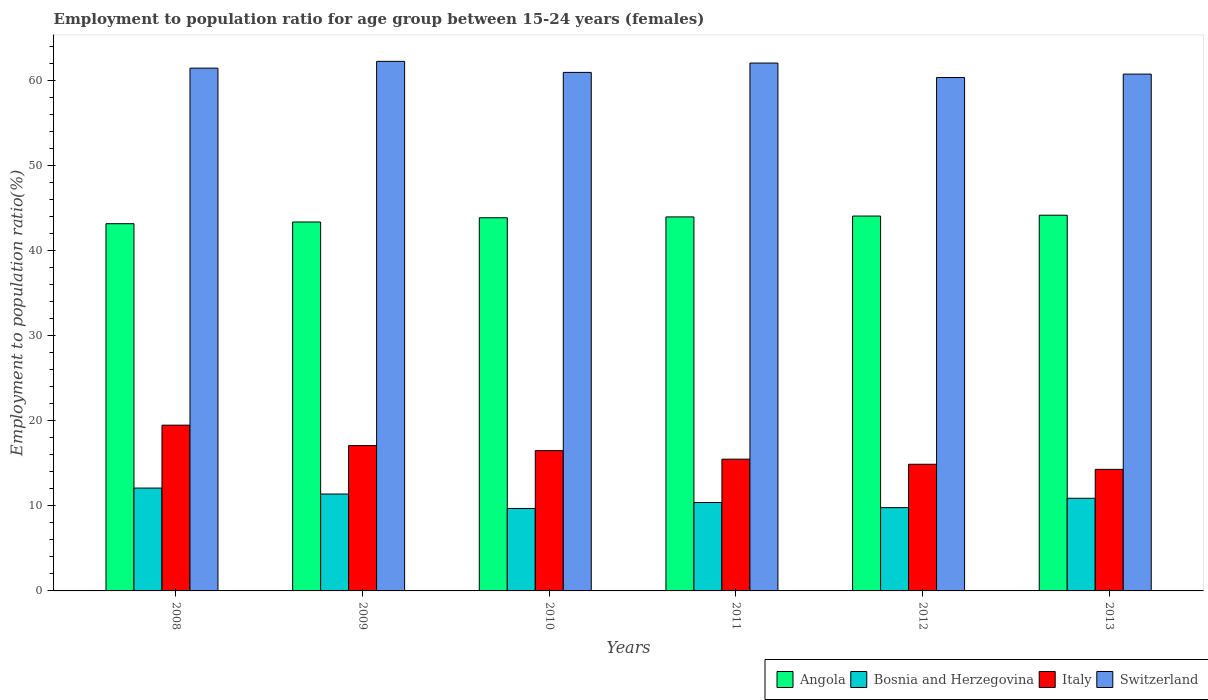How many different coloured bars are there?
Offer a very short reply. 4. How many bars are there on the 2nd tick from the left?
Provide a succinct answer. 4. How many bars are there on the 2nd tick from the right?
Your answer should be compact. 4. What is the employment to population ratio in Switzerland in 2010?
Provide a short and direct response. 61. Across all years, what is the minimum employment to population ratio in Bosnia and Herzegovina?
Your answer should be very brief. 9.7. What is the total employment to population ratio in Angola in the graph?
Keep it short and to the point. 262.8. What is the difference between the employment to population ratio in Bosnia and Herzegovina in 2011 and that in 2012?
Keep it short and to the point. 0.6. What is the difference between the employment to population ratio in Switzerland in 2010 and the employment to population ratio in Italy in 2009?
Your answer should be very brief. 43.9. What is the average employment to population ratio in Switzerland per year?
Your response must be concise. 61.35. In the year 2012, what is the difference between the employment to population ratio in Italy and employment to population ratio in Angola?
Make the answer very short. -29.2. What is the ratio of the employment to population ratio in Italy in 2009 to that in 2013?
Keep it short and to the point. 1.2. What is the difference between the highest and the second highest employment to population ratio in Angola?
Ensure brevity in your answer.  0.1. What is the difference between the highest and the lowest employment to population ratio in Italy?
Offer a terse response. 5.2. Is the sum of the employment to population ratio in Bosnia and Herzegovina in 2008 and 2012 greater than the maximum employment to population ratio in Switzerland across all years?
Your answer should be compact. No. What does the 1st bar from the left in 2012 represents?
Ensure brevity in your answer.  Angola. Does the graph contain grids?
Keep it short and to the point. No. Where does the legend appear in the graph?
Provide a short and direct response. Bottom right. How are the legend labels stacked?
Offer a very short reply. Horizontal. What is the title of the graph?
Make the answer very short. Employment to population ratio for age group between 15-24 years (females). What is the label or title of the Y-axis?
Ensure brevity in your answer.  Employment to population ratio(%). What is the Employment to population ratio(%) of Angola in 2008?
Your response must be concise. 43.2. What is the Employment to population ratio(%) in Bosnia and Herzegovina in 2008?
Give a very brief answer. 12.1. What is the Employment to population ratio(%) of Switzerland in 2008?
Keep it short and to the point. 61.5. What is the Employment to population ratio(%) of Angola in 2009?
Offer a terse response. 43.4. What is the Employment to population ratio(%) in Bosnia and Herzegovina in 2009?
Your answer should be compact. 11.4. What is the Employment to population ratio(%) of Italy in 2009?
Offer a terse response. 17.1. What is the Employment to population ratio(%) in Switzerland in 2009?
Offer a terse response. 62.3. What is the Employment to population ratio(%) of Angola in 2010?
Give a very brief answer. 43.9. What is the Employment to population ratio(%) of Bosnia and Herzegovina in 2010?
Make the answer very short. 9.7. What is the Employment to population ratio(%) in Italy in 2010?
Offer a very short reply. 16.5. What is the Employment to population ratio(%) of Switzerland in 2010?
Give a very brief answer. 61. What is the Employment to population ratio(%) in Bosnia and Herzegovina in 2011?
Provide a succinct answer. 10.4. What is the Employment to population ratio(%) in Italy in 2011?
Your response must be concise. 15.5. What is the Employment to population ratio(%) of Switzerland in 2011?
Offer a terse response. 62.1. What is the Employment to population ratio(%) in Angola in 2012?
Your answer should be very brief. 44.1. What is the Employment to population ratio(%) in Bosnia and Herzegovina in 2012?
Make the answer very short. 9.8. What is the Employment to population ratio(%) of Italy in 2012?
Offer a terse response. 14.9. What is the Employment to population ratio(%) of Switzerland in 2012?
Your answer should be compact. 60.4. What is the Employment to population ratio(%) in Angola in 2013?
Offer a very short reply. 44.2. What is the Employment to population ratio(%) of Bosnia and Herzegovina in 2013?
Provide a short and direct response. 10.9. What is the Employment to population ratio(%) of Italy in 2013?
Make the answer very short. 14.3. What is the Employment to population ratio(%) in Switzerland in 2013?
Provide a short and direct response. 60.8. Across all years, what is the maximum Employment to population ratio(%) of Angola?
Provide a succinct answer. 44.2. Across all years, what is the maximum Employment to population ratio(%) in Bosnia and Herzegovina?
Your answer should be very brief. 12.1. Across all years, what is the maximum Employment to population ratio(%) in Switzerland?
Keep it short and to the point. 62.3. Across all years, what is the minimum Employment to population ratio(%) of Angola?
Ensure brevity in your answer.  43.2. Across all years, what is the minimum Employment to population ratio(%) in Bosnia and Herzegovina?
Provide a succinct answer. 9.7. Across all years, what is the minimum Employment to population ratio(%) in Italy?
Your answer should be compact. 14.3. Across all years, what is the minimum Employment to population ratio(%) in Switzerland?
Give a very brief answer. 60.4. What is the total Employment to population ratio(%) of Angola in the graph?
Give a very brief answer. 262.8. What is the total Employment to population ratio(%) of Bosnia and Herzegovina in the graph?
Give a very brief answer. 64.3. What is the total Employment to population ratio(%) in Italy in the graph?
Give a very brief answer. 97.8. What is the total Employment to population ratio(%) of Switzerland in the graph?
Provide a short and direct response. 368.1. What is the difference between the Employment to population ratio(%) of Angola in 2008 and that in 2009?
Ensure brevity in your answer.  -0.2. What is the difference between the Employment to population ratio(%) of Bosnia and Herzegovina in 2008 and that in 2009?
Your answer should be very brief. 0.7. What is the difference between the Employment to population ratio(%) of Italy in 2008 and that in 2009?
Give a very brief answer. 2.4. What is the difference between the Employment to population ratio(%) in Switzerland in 2008 and that in 2009?
Your response must be concise. -0.8. What is the difference between the Employment to population ratio(%) of Bosnia and Herzegovina in 2008 and that in 2010?
Your response must be concise. 2.4. What is the difference between the Employment to population ratio(%) of Switzerland in 2008 and that in 2010?
Offer a very short reply. 0.5. What is the difference between the Employment to population ratio(%) of Italy in 2008 and that in 2011?
Provide a short and direct response. 4. What is the difference between the Employment to population ratio(%) of Switzerland in 2008 and that in 2012?
Your response must be concise. 1.1. What is the difference between the Employment to population ratio(%) in Angola in 2008 and that in 2013?
Keep it short and to the point. -1. What is the difference between the Employment to population ratio(%) in Bosnia and Herzegovina in 2008 and that in 2013?
Your answer should be very brief. 1.2. What is the difference between the Employment to population ratio(%) of Italy in 2008 and that in 2013?
Your answer should be very brief. 5.2. What is the difference between the Employment to population ratio(%) in Switzerland in 2008 and that in 2013?
Provide a succinct answer. 0.7. What is the difference between the Employment to population ratio(%) of Angola in 2009 and that in 2010?
Provide a succinct answer. -0.5. What is the difference between the Employment to population ratio(%) of Italy in 2009 and that in 2010?
Provide a short and direct response. 0.6. What is the difference between the Employment to population ratio(%) in Angola in 2009 and that in 2011?
Your response must be concise. -0.6. What is the difference between the Employment to population ratio(%) of Bosnia and Herzegovina in 2009 and that in 2011?
Make the answer very short. 1. What is the difference between the Employment to population ratio(%) in Italy in 2009 and that in 2011?
Your answer should be compact. 1.6. What is the difference between the Employment to population ratio(%) of Switzerland in 2009 and that in 2011?
Give a very brief answer. 0.2. What is the difference between the Employment to population ratio(%) in Switzerland in 2009 and that in 2012?
Make the answer very short. 1.9. What is the difference between the Employment to population ratio(%) of Bosnia and Herzegovina in 2009 and that in 2013?
Make the answer very short. 0.5. What is the difference between the Employment to population ratio(%) in Switzerland in 2010 and that in 2011?
Make the answer very short. -1.1. What is the difference between the Employment to population ratio(%) of Bosnia and Herzegovina in 2010 and that in 2012?
Provide a succinct answer. -0.1. What is the difference between the Employment to population ratio(%) of Angola in 2010 and that in 2013?
Your answer should be very brief. -0.3. What is the difference between the Employment to population ratio(%) in Bosnia and Herzegovina in 2010 and that in 2013?
Give a very brief answer. -1.2. What is the difference between the Employment to population ratio(%) of Angola in 2011 and that in 2012?
Keep it short and to the point. -0.1. What is the difference between the Employment to population ratio(%) of Italy in 2011 and that in 2012?
Your response must be concise. 0.6. What is the difference between the Employment to population ratio(%) of Angola in 2011 and that in 2013?
Your response must be concise. -0.2. What is the difference between the Employment to population ratio(%) of Italy in 2011 and that in 2013?
Give a very brief answer. 1.2. What is the difference between the Employment to population ratio(%) of Switzerland in 2011 and that in 2013?
Make the answer very short. 1.3. What is the difference between the Employment to population ratio(%) in Italy in 2012 and that in 2013?
Offer a very short reply. 0.6. What is the difference between the Employment to population ratio(%) of Switzerland in 2012 and that in 2013?
Keep it short and to the point. -0.4. What is the difference between the Employment to population ratio(%) of Angola in 2008 and the Employment to population ratio(%) of Bosnia and Herzegovina in 2009?
Give a very brief answer. 31.8. What is the difference between the Employment to population ratio(%) in Angola in 2008 and the Employment to population ratio(%) in Italy in 2009?
Make the answer very short. 26.1. What is the difference between the Employment to population ratio(%) of Angola in 2008 and the Employment to population ratio(%) of Switzerland in 2009?
Offer a terse response. -19.1. What is the difference between the Employment to population ratio(%) of Bosnia and Herzegovina in 2008 and the Employment to population ratio(%) of Switzerland in 2009?
Keep it short and to the point. -50.2. What is the difference between the Employment to population ratio(%) of Italy in 2008 and the Employment to population ratio(%) of Switzerland in 2009?
Provide a succinct answer. -42.8. What is the difference between the Employment to population ratio(%) in Angola in 2008 and the Employment to population ratio(%) in Bosnia and Herzegovina in 2010?
Your answer should be compact. 33.5. What is the difference between the Employment to population ratio(%) in Angola in 2008 and the Employment to population ratio(%) in Italy in 2010?
Give a very brief answer. 26.7. What is the difference between the Employment to population ratio(%) in Angola in 2008 and the Employment to population ratio(%) in Switzerland in 2010?
Ensure brevity in your answer.  -17.8. What is the difference between the Employment to population ratio(%) in Bosnia and Herzegovina in 2008 and the Employment to population ratio(%) in Italy in 2010?
Offer a very short reply. -4.4. What is the difference between the Employment to population ratio(%) of Bosnia and Herzegovina in 2008 and the Employment to population ratio(%) of Switzerland in 2010?
Offer a terse response. -48.9. What is the difference between the Employment to population ratio(%) in Italy in 2008 and the Employment to population ratio(%) in Switzerland in 2010?
Your answer should be compact. -41.5. What is the difference between the Employment to population ratio(%) of Angola in 2008 and the Employment to population ratio(%) of Bosnia and Herzegovina in 2011?
Your answer should be compact. 32.8. What is the difference between the Employment to population ratio(%) of Angola in 2008 and the Employment to population ratio(%) of Italy in 2011?
Ensure brevity in your answer.  27.7. What is the difference between the Employment to population ratio(%) in Angola in 2008 and the Employment to population ratio(%) in Switzerland in 2011?
Your answer should be compact. -18.9. What is the difference between the Employment to population ratio(%) in Italy in 2008 and the Employment to population ratio(%) in Switzerland in 2011?
Keep it short and to the point. -42.6. What is the difference between the Employment to population ratio(%) of Angola in 2008 and the Employment to population ratio(%) of Bosnia and Herzegovina in 2012?
Provide a short and direct response. 33.4. What is the difference between the Employment to population ratio(%) in Angola in 2008 and the Employment to population ratio(%) in Italy in 2012?
Give a very brief answer. 28.3. What is the difference between the Employment to population ratio(%) of Angola in 2008 and the Employment to population ratio(%) of Switzerland in 2012?
Your response must be concise. -17.2. What is the difference between the Employment to population ratio(%) in Bosnia and Herzegovina in 2008 and the Employment to population ratio(%) in Switzerland in 2012?
Provide a succinct answer. -48.3. What is the difference between the Employment to population ratio(%) in Italy in 2008 and the Employment to population ratio(%) in Switzerland in 2012?
Keep it short and to the point. -40.9. What is the difference between the Employment to population ratio(%) of Angola in 2008 and the Employment to population ratio(%) of Bosnia and Herzegovina in 2013?
Provide a succinct answer. 32.3. What is the difference between the Employment to population ratio(%) of Angola in 2008 and the Employment to population ratio(%) of Italy in 2013?
Give a very brief answer. 28.9. What is the difference between the Employment to population ratio(%) of Angola in 2008 and the Employment to population ratio(%) of Switzerland in 2013?
Offer a terse response. -17.6. What is the difference between the Employment to population ratio(%) in Bosnia and Herzegovina in 2008 and the Employment to population ratio(%) in Switzerland in 2013?
Ensure brevity in your answer.  -48.7. What is the difference between the Employment to population ratio(%) in Italy in 2008 and the Employment to population ratio(%) in Switzerland in 2013?
Your response must be concise. -41.3. What is the difference between the Employment to population ratio(%) of Angola in 2009 and the Employment to population ratio(%) of Bosnia and Herzegovina in 2010?
Provide a short and direct response. 33.7. What is the difference between the Employment to population ratio(%) of Angola in 2009 and the Employment to population ratio(%) of Italy in 2010?
Provide a short and direct response. 26.9. What is the difference between the Employment to population ratio(%) of Angola in 2009 and the Employment to population ratio(%) of Switzerland in 2010?
Your response must be concise. -17.6. What is the difference between the Employment to population ratio(%) in Bosnia and Herzegovina in 2009 and the Employment to population ratio(%) in Switzerland in 2010?
Keep it short and to the point. -49.6. What is the difference between the Employment to population ratio(%) in Italy in 2009 and the Employment to population ratio(%) in Switzerland in 2010?
Offer a very short reply. -43.9. What is the difference between the Employment to population ratio(%) in Angola in 2009 and the Employment to population ratio(%) in Bosnia and Herzegovina in 2011?
Your response must be concise. 33. What is the difference between the Employment to population ratio(%) in Angola in 2009 and the Employment to population ratio(%) in Italy in 2011?
Your response must be concise. 27.9. What is the difference between the Employment to population ratio(%) in Angola in 2009 and the Employment to population ratio(%) in Switzerland in 2011?
Offer a terse response. -18.7. What is the difference between the Employment to population ratio(%) in Bosnia and Herzegovina in 2009 and the Employment to population ratio(%) in Switzerland in 2011?
Ensure brevity in your answer.  -50.7. What is the difference between the Employment to population ratio(%) in Italy in 2009 and the Employment to population ratio(%) in Switzerland in 2011?
Provide a short and direct response. -45. What is the difference between the Employment to population ratio(%) in Angola in 2009 and the Employment to population ratio(%) in Bosnia and Herzegovina in 2012?
Provide a succinct answer. 33.6. What is the difference between the Employment to population ratio(%) in Angola in 2009 and the Employment to population ratio(%) in Switzerland in 2012?
Provide a short and direct response. -17. What is the difference between the Employment to population ratio(%) in Bosnia and Herzegovina in 2009 and the Employment to population ratio(%) in Switzerland in 2012?
Offer a very short reply. -49. What is the difference between the Employment to population ratio(%) of Italy in 2009 and the Employment to population ratio(%) of Switzerland in 2012?
Make the answer very short. -43.3. What is the difference between the Employment to population ratio(%) of Angola in 2009 and the Employment to population ratio(%) of Bosnia and Herzegovina in 2013?
Offer a very short reply. 32.5. What is the difference between the Employment to population ratio(%) in Angola in 2009 and the Employment to population ratio(%) in Italy in 2013?
Make the answer very short. 29.1. What is the difference between the Employment to population ratio(%) in Angola in 2009 and the Employment to population ratio(%) in Switzerland in 2013?
Give a very brief answer. -17.4. What is the difference between the Employment to population ratio(%) of Bosnia and Herzegovina in 2009 and the Employment to population ratio(%) of Italy in 2013?
Offer a terse response. -2.9. What is the difference between the Employment to population ratio(%) of Bosnia and Herzegovina in 2009 and the Employment to population ratio(%) of Switzerland in 2013?
Your response must be concise. -49.4. What is the difference between the Employment to population ratio(%) of Italy in 2009 and the Employment to population ratio(%) of Switzerland in 2013?
Keep it short and to the point. -43.7. What is the difference between the Employment to population ratio(%) of Angola in 2010 and the Employment to population ratio(%) of Bosnia and Herzegovina in 2011?
Your response must be concise. 33.5. What is the difference between the Employment to population ratio(%) in Angola in 2010 and the Employment to population ratio(%) in Italy in 2011?
Your answer should be compact. 28.4. What is the difference between the Employment to population ratio(%) of Angola in 2010 and the Employment to population ratio(%) of Switzerland in 2011?
Your response must be concise. -18.2. What is the difference between the Employment to population ratio(%) of Bosnia and Herzegovina in 2010 and the Employment to population ratio(%) of Italy in 2011?
Your response must be concise. -5.8. What is the difference between the Employment to population ratio(%) in Bosnia and Herzegovina in 2010 and the Employment to population ratio(%) in Switzerland in 2011?
Your answer should be compact. -52.4. What is the difference between the Employment to population ratio(%) in Italy in 2010 and the Employment to population ratio(%) in Switzerland in 2011?
Ensure brevity in your answer.  -45.6. What is the difference between the Employment to population ratio(%) in Angola in 2010 and the Employment to population ratio(%) in Bosnia and Herzegovina in 2012?
Make the answer very short. 34.1. What is the difference between the Employment to population ratio(%) in Angola in 2010 and the Employment to population ratio(%) in Switzerland in 2012?
Offer a terse response. -16.5. What is the difference between the Employment to population ratio(%) of Bosnia and Herzegovina in 2010 and the Employment to population ratio(%) of Switzerland in 2012?
Offer a very short reply. -50.7. What is the difference between the Employment to population ratio(%) in Italy in 2010 and the Employment to population ratio(%) in Switzerland in 2012?
Make the answer very short. -43.9. What is the difference between the Employment to population ratio(%) of Angola in 2010 and the Employment to population ratio(%) of Bosnia and Herzegovina in 2013?
Your answer should be very brief. 33. What is the difference between the Employment to population ratio(%) of Angola in 2010 and the Employment to population ratio(%) of Italy in 2013?
Your answer should be very brief. 29.6. What is the difference between the Employment to population ratio(%) in Angola in 2010 and the Employment to population ratio(%) in Switzerland in 2013?
Offer a terse response. -16.9. What is the difference between the Employment to population ratio(%) of Bosnia and Herzegovina in 2010 and the Employment to population ratio(%) of Switzerland in 2013?
Ensure brevity in your answer.  -51.1. What is the difference between the Employment to population ratio(%) in Italy in 2010 and the Employment to population ratio(%) in Switzerland in 2013?
Offer a terse response. -44.3. What is the difference between the Employment to population ratio(%) in Angola in 2011 and the Employment to population ratio(%) in Bosnia and Herzegovina in 2012?
Keep it short and to the point. 34.2. What is the difference between the Employment to population ratio(%) of Angola in 2011 and the Employment to population ratio(%) of Italy in 2012?
Your answer should be very brief. 29.1. What is the difference between the Employment to population ratio(%) in Angola in 2011 and the Employment to population ratio(%) in Switzerland in 2012?
Provide a succinct answer. -16.4. What is the difference between the Employment to population ratio(%) of Bosnia and Herzegovina in 2011 and the Employment to population ratio(%) of Italy in 2012?
Provide a short and direct response. -4.5. What is the difference between the Employment to population ratio(%) in Bosnia and Herzegovina in 2011 and the Employment to population ratio(%) in Switzerland in 2012?
Offer a terse response. -50. What is the difference between the Employment to population ratio(%) of Italy in 2011 and the Employment to population ratio(%) of Switzerland in 2012?
Provide a short and direct response. -44.9. What is the difference between the Employment to population ratio(%) of Angola in 2011 and the Employment to population ratio(%) of Bosnia and Herzegovina in 2013?
Give a very brief answer. 33.1. What is the difference between the Employment to population ratio(%) of Angola in 2011 and the Employment to population ratio(%) of Italy in 2013?
Your response must be concise. 29.7. What is the difference between the Employment to population ratio(%) in Angola in 2011 and the Employment to population ratio(%) in Switzerland in 2013?
Provide a short and direct response. -16.8. What is the difference between the Employment to population ratio(%) of Bosnia and Herzegovina in 2011 and the Employment to population ratio(%) of Switzerland in 2013?
Provide a short and direct response. -50.4. What is the difference between the Employment to population ratio(%) in Italy in 2011 and the Employment to population ratio(%) in Switzerland in 2013?
Offer a terse response. -45.3. What is the difference between the Employment to population ratio(%) in Angola in 2012 and the Employment to population ratio(%) in Bosnia and Herzegovina in 2013?
Provide a short and direct response. 33.2. What is the difference between the Employment to population ratio(%) in Angola in 2012 and the Employment to population ratio(%) in Italy in 2013?
Offer a terse response. 29.8. What is the difference between the Employment to population ratio(%) of Angola in 2012 and the Employment to population ratio(%) of Switzerland in 2013?
Your answer should be compact. -16.7. What is the difference between the Employment to population ratio(%) of Bosnia and Herzegovina in 2012 and the Employment to population ratio(%) of Switzerland in 2013?
Your answer should be very brief. -51. What is the difference between the Employment to population ratio(%) in Italy in 2012 and the Employment to population ratio(%) in Switzerland in 2013?
Your answer should be compact. -45.9. What is the average Employment to population ratio(%) in Angola per year?
Offer a very short reply. 43.8. What is the average Employment to population ratio(%) of Bosnia and Herzegovina per year?
Keep it short and to the point. 10.72. What is the average Employment to population ratio(%) of Italy per year?
Your answer should be compact. 16.3. What is the average Employment to population ratio(%) in Switzerland per year?
Make the answer very short. 61.35. In the year 2008, what is the difference between the Employment to population ratio(%) of Angola and Employment to population ratio(%) of Bosnia and Herzegovina?
Give a very brief answer. 31.1. In the year 2008, what is the difference between the Employment to population ratio(%) of Angola and Employment to population ratio(%) of Italy?
Your response must be concise. 23.7. In the year 2008, what is the difference between the Employment to population ratio(%) in Angola and Employment to population ratio(%) in Switzerland?
Give a very brief answer. -18.3. In the year 2008, what is the difference between the Employment to population ratio(%) of Bosnia and Herzegovina and Employment to population ratio(%) of Switzerland?
Offer a very short reply. -49.4. In the year 2008, what is the difference between the Employment to population ratio(%) in Italy and Employment to population ratio(%) in Switzerland?
Offer a very short reply. -42. In the year 2009, what is the difference between the Employment to population ratio(%) of Angola and Employment to population ratio(%) of Bosnia and Herzegovina?
Give a very brief answer. 32. In the year 2009, what is the difference between the Employment to population ratio(%) of Angola and Employment to population ratio(%) of Italy?
Give a very brief answer. 26.3. In the year 2009, what is the difference between the Employment to population ratio(%) in Angola and Employment to population ratio(%) in Switzerland?
Ensure brevity in your answer.  -18.9. In the year 2009, what is the difference between the Employment to population ratio(%) in Bosnia and Herzegovina and Employment to population ratio(%) in Italy?
Ensure brevity in your answer.  -5.7. In the year 2009, what is the difference between the Employment to population ratio(%) in Bosnia and Herzegovina and Employment to population ratio(%) in Switzerland?
Ensure brevity in your answer.  -50.9. In the year 2009, what is the difference between the Employment to population ratio(%) of Italy and Employment to population ratio(%) of Switzerland?
Your response must be concise. -45.2. In the year 2010, what is the difference between the Employment to population ratio(%) of Angola and Employment to population ratio(%) of Bosnia and Herzegovina?
Offer a very short reply. 34.2. In the year 2010, what is the difference between the Employment to population ratio(%) in Angola and Employment to population ratio(%) in Italy?
Provide a short and direct response. 27.4. In the year 2010, what is the difference between the Employment to population ratio(%) of Angola and Employment to population ratio(%) of Switzerland?
Make the answer very short. -17.1. In the year 2010, what is the difference between the Employment to population ratio(%) of Bosnia and Herzegovina and Employment to population ratio(%) of Italy?
Make the answer very short. -6.8. In the year 2010, what is the difference between the Employment to population ratio(%) in Bosnia and Herzegovina and Employment to population ratio(%) in Switzerland?
Your answer should be compact. -51.3. In the year 2010, what is the difference between the Employment to population ratio(%) of Italy and Employment to population ratio(%) of Switzerland?
Your response must be concise. -44.5. In the year 2011, what is the difference between the Employment to population ratio(%) of Angola and Employment to population ratio(%) of Bosnia and Herzegovina?
Your response must be concise. 33.6. In the year 2011, what is the difference between the Employment to population ratio(%) in Angola and Employment to population ratio(%) in Switzerland?
Your response must be concise. -18.1. In the year 2011, what is the difference between the Employment to population ratio(%) of Bosnia and Herzegovina and Employment to population ratio(%) of Italy?
Your answer should be compact. -5.1. In the year 2011, what is the difference between the Employment to population ratio(%) in Bosnia and Herzegovina and Employment to population ratio(%) in Switzerland?
Provide a succinct answer. -51.7. In the year 2011, what is the difference between the Employment to population ratio(%) of Italy and Employment to population ratio(%) of Switzerland?
Keep it short and to the point. -46.6. In the year 2012, what is the difference between the Employment to population ratio(%) in Angola and Employment to population ratio(%) in Bosnia and Herzegovina?
Keep it short and to the point. 34.3. In the year 2012, what is the difference between the Employment to population ratio(%) of Angola and Employment to population ratio(%) of Italy?
Make the answer very short. 29.2. In the year 2012, what is the difference between the Employment to population ratio(%) of Angola and Employment to population ratio(%) of Switzerland?
Ensure brevity in your answer.  -16.3. In the year 2012, what is the difference between the Employment to population ratio(%) of Bosnia and Herzegovina and Employment to population ratio(%) of Italy?
Offer a very short reply. -5.1. In the year 2012, what is the difference between the Employment to population ratio(%) in Bosnia and Herzegovina and Employment to population ratio(%) in Switzerland?
Make the answer very short. -50.6. In the year 2012, what is the difference between the Employment to population ratio(%) of Italy and Employment to population ratio(%) of Switzerland?
Your response must be concise. -45.5. In the year 2013, what is the difference between the Employment to population ratio(%) of Angola and Employment to population ratio(%) of Bosnia and Herzegovina?
Provide a succinct answer. 33.3. In the year 2013, what is the difference between the Employment to population ratio(%) in Angola and Employment to population ratio(%) in Italy?
Your answer should be very brief. 29.9. In the year 2013, what is the difference between the Employment to population ratio(%) of Angola and Employment to population ratio(%) of Switzerland?
Make the answer very short. -16.6. In the year 2013, what is the difference between the Employment to population ratio(%) in Bosnia and Herzegovina and Employment to population ratio(%) in Switzerland?
Ensure brevity in your answer.  -49.9. In the year 2013, what is the difference between the Employment to population ratio(%) in Italy and Employment to population ratio(%) in Switzerland?
Ensure brevity in your answer.  -46.5. What is the ratio of the Employment to population ratio(%) of Angola in 2008 to that in 2009?
Your answer should be very brief. 1. What is the ratio of the Employment to population ratio(%) in Bosnia and Herzegovina in 2008 to that in 2009?
Provide a short and direct response. 1.06. What is the ratio of the Employment to population ratio(%) in Italy in 2008 to that in 2009?
Keep it short and to the point. 1.14. What is the ratio of the Employment to population ratio(%) of Switzerland in 2008 to that in 2009?
Your response must be concise. 0.99. What is the ratio of the Employment to population ratio(%) in Angola in 2008 to that in 2010?
Keep it short and to the point. 0.98. What is the ratio of the Employment to population ratio(%) in Bosnia and Herzegovina in 2008 to that in 2010?
Provide a short and direct response. 1.25. What is the ratio of the Employment to population ratio(%) in Italy in 2008 to that in 2010?
Offer a very short reply. 1.18. What is the ratio of the Employment to population ratio(%) in Switzerland in 2008 to that in 2010?
Your answer should be compact. 1.01. What is the ratio of the Employment to population ratio(%) of Angola in 2008 to that in 2011?
Keep it short and to the point. 0.98. What is the ratio of the Employment to population ratio(%) of Bosnia and Herzegovina in 2008 to that in 2011?
Keep it short and to the point. 1.16. What is the ratio of the Employment to population ratio(%) of Italy in 2008 to that in 2011?
Give a very brief answer. 1.26. What is the ratio of the Employment to population ratio(%) in Switzerland in 2008 to that in 2011?
Offer a very short reply. 0.99. What is the ratio of the Employment to population ratio(%) in Angola in 2008 to that in 2012?
Your answer should be compact. 0.98. What is the ratio of the Employment to population ratio(%) in Bosnia and Herzegovina in 2008 to that in 2012?
Your answer should be compact. 1.23. What is the ratio of the Employment to population ratio(%) of Italy in 2008 to that in 2012?
Your response must be concise. 1.31. What is the ratio of the Employment to population ratio(%) of Switzerland in 2008 to that in 2012?
Make the answer very short. 1.02. What is the ratio of the Employment to population ratio(%) of Angola in 2008 to that in 2013?
Ensure brevity in your answer.  0.98. What is the ratio of the Employment to population ratio(%) of Bosnia and Herzegovina in 2008 to that in 2013?
Provide a succinct answer. 1.11. What is the ratio of the Employment to population ratio(%) of Italy in 2008 to that in 2013?
Make the answer very short. 1.36. What is the ratio of the Employment to population ratio(%) of Switzerland in 2008 to that in 2013?
Make the answer very short. 1.01. What is the ratio of the Employment to population ratio(%) of Bosnia and Herzegovina in 2009 to that in 2010?
Your answer should be very brief. 1.18. What is the ratio of the Employment to population ratio(%) of Italy in 2009 to that in 2010?
Provide a succinct answer. 1.04. What is the ratio of the Employment to population ratio(%) of Switzerland in 2009 to that in 2010?
Make the answer very short. 1.02. What is the ratio of the Employment to population ratio(%) of Angola in 2009 to that in 2011?
Provide a succinct answer. 0.99. What is the ratio of the Employment to population ratio(%) in Bosnia and Herzegovina in 2009 to that in 2011?
Give a very brief answer. 1.1. What is the ratio of the Employment to population ratio(%) in Italy in 2009 to that in 2011?
Keep it short and to the point. 1.1. What is the ratio of the Employment to population ratio(%) of Switzerland in 2009 to that in 2011?
Keep it short and to the point. 1. What is the ratio of the Employment to population ratio(%) in Angola in 2009 to that in 2012?
Provide a succinct answer. 0.98. What is the ratio of the Employment to population ratio(%) in Bosnia and Herzegovina in 2009 to that in 2012?
Make the answer very short. 1.16. What is the ratio of the Employment to population ratio(%) in Italy in 2009 to that in 2012?
Offer a terse response. 1.15. What is the ratio of the Employment to population ratio(%) in Switzerland in 2009 to that in 2012?
Keep it short and to the point. 1.03. What is the ratio of the Employment to population ratio(%) in Angola in 2009 to that in 2013?
Provide a short and direct response. 0.98. What is the ratio of the Employment to population ratio(%) of Bosnia and Herzegovina in 2009 to that in 2013?
Your answer should be compact. 1.05. What is the ratio of the Employment to population ratio(%) of Italy in 2009 to that in 2013?
Offer a very short reply. 1.2. What is the ratio of the Employment to population ratio(%) in Switzerland in 2009 to that in 2013?
Offer a terse response. 1.02. What is the ratio of the Employment to population ratio(%) in Angola in 2010 to that in 2011?
Your answer should be very brief. 1. What is the ratio of the Employment to population ratio(%) of Bosnia and Herzegovina in 2010 to that in 2011?
Ensure brevity in your answer.  0.93. What is the ratio of the Employment to population ratio(%) in Italy in 2010 to that in 2011?
Make the answer very short. 1.06. What is the ratio of the Employment to population ratio(%) of Switzerland in 2010 to that in 2011?
Ensure brevity in your answer.  0.98. What is the ratio of the Employment to population ratio(%) in Italy in 2010 to that in 2012?
Your response must be concise. 1.11. What is the ratio of the Employment to population ratio(%) in Switzerland in 2010 to that in 2012?
Your answer should be very brief. 1.01. What is the ratio of the Employment to population ratio(%) in Angola in 2010 to that in 2013?
Offer a very short reply. 0.99. What is the ratio of the Employment to population ratio(%) of Bosnia and Herzegovina in 2010 to that in 2013?
Provide a succinct answer. 0.89. What is the ratio of the Employment to population ratio(%) in Italy in 2010 to that in 2013?
Give a very brief answer. 1.15. What is the ratio of the Employment to population ratio(%) in Switzerland in 2010 to that in 2013?
Your answer should be very brief. 1. What is the ratio of the Employment to population ratio(%) in Angola in 2011 to that in 2012?
Give a very brief answer. 1. What is the ratio of the Employment to population ratio(%) in Bosnia and Herzegovina in 2011 to that in 2012?
Your answer should be very brief. 1.06. What is the ratio of the Employment to population ratio(%) of Italy in 2011 to that in 2012?
Offer a terse response. 1.04. What is the ratio of the Employment to population ratio(%) in Switzerland in 2011 to that in 2012?
Your response must be concise. 1.03. What is the ratio of the Employment to population ratio(%) in Bosnia and Herzegovina in 2011 to that in 2013?
Make the answer very short. 0.95. What is the ratio of the Employment to population ratio(%) in Italy in 2011 to that in 2013?
Provide a short and direct response. 1.08. What is the ratio of the Employment to population ratio(%) of Switzerland in 2011 to that in 2013?
Your answer should be compact. 1.02. What is the ratio of the Employment to population ratio(%) of Bosnia and Herzegovina in 2012 to that in 2013?
Your response must be concise. 0.9. What is the ratio of the Employment to population ratio(%) in Italy in 2012 to that in 2013?
Your response must be concise. 1.04. What is the ratio of the Employment to population ratio(%) in Switzerland in 2012 to that in 2013?
Your response must be concise. 0.99. What is the difference between the highest and the second highest Employment to population ratio(%) of Bosnia and Herzegovina?
Offer a very short reply. 0.7. What is the difference between the highest and the second highest Employment to population ratio(%) in Switzerland?
Offer a terse response. 0.2. What is the difference between the highest and the lowest Employment to population ratio(%) of Angola?
Offer a terse response. 1. What is the difference between the highest and the lowest Employment to population ratio(%) in Italy?
Make the answer very short. 5.2. 